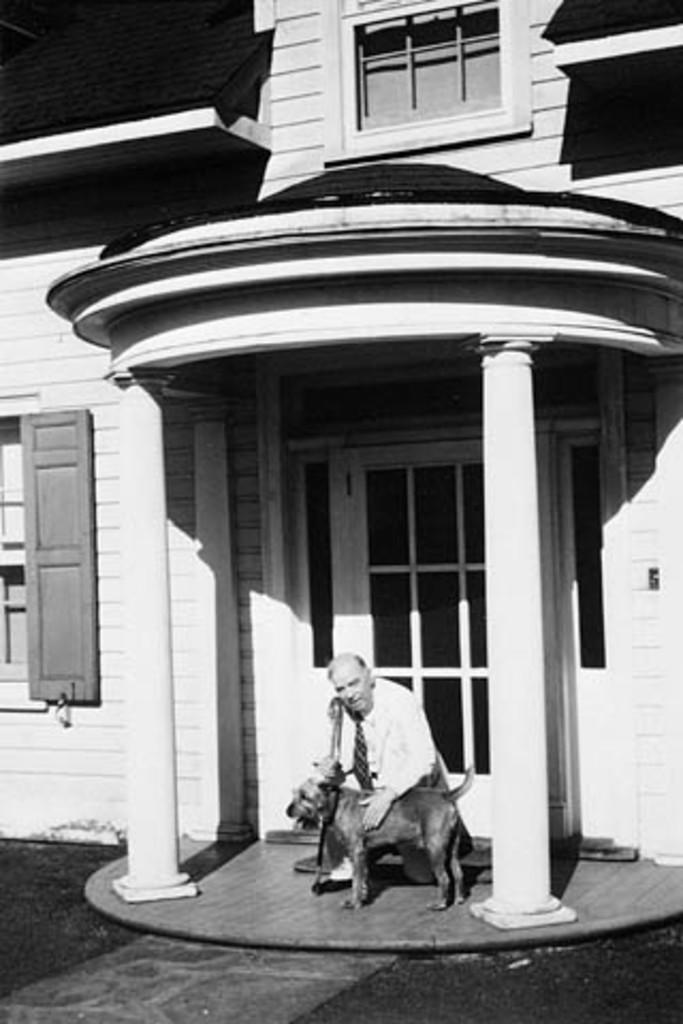What is the color scheme of the image? The image is black and white. What can be seen in the background of the image? There is a building in the background of the image. Who is present in the image? There is a man and a dog in the image. What architectural features are visible in the image? There is a window and a door in the image. Can you see any frogs jumping on the hill in the image? There is no hill or frogs present in the image. What type of hill is the dog standing on in the image? There is no hill in the image; it is a black and white image featuring a man, a dog, a building, a window, and a door. 